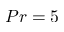Convert formula to latex. <formula><loc_0><loc_0><loc_500><loc_500>P r = 5</formula> 